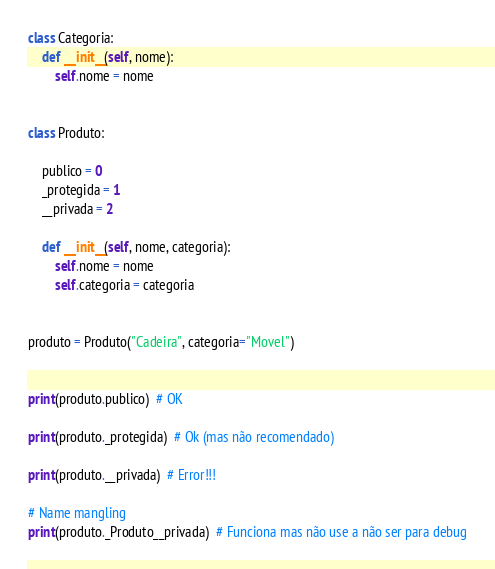Convert code to text. <code><loc_0><loc_0><loc_500><loc_500><_Python_>class Categoria:
    def __init__(self, nome):
        self.nome = nome


class Produto:

    publico = 0
    _protegida = 1
    __privada = 2

    def __init__(self, nome, categoria):
        self.nome = nome
        self.categoria = categoria


produto = Produto("Cadeira", categoria="Movel")


print(produto.publico)  # OK

print(produto._protegida)  # Ok (mas não recomendado)

print(produto.__privada)  # Error!!!

# Name mangling
print(produto._Produto__privada)  # Funciona mas não use a não ser para debug
</code> 